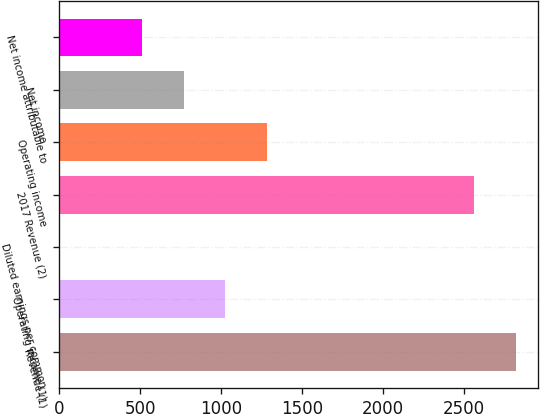<chart> <loc_0><loc_0><loc_500><loc_500><bar_chart><fcel>Revenue (1)<fcel>Operating income (1)<fcel>Diluted earnings per common<fcel>2017 Revenue (2)<fcel>Operating income<fcel>Net income<fcel>Net income attributable to<nl><fcel>2818.5<fcel>1026.66<fcel>0.66<fcel>2562<fcel>1283.16<fcel>770.16<fcel>513.66<nl></chart> 